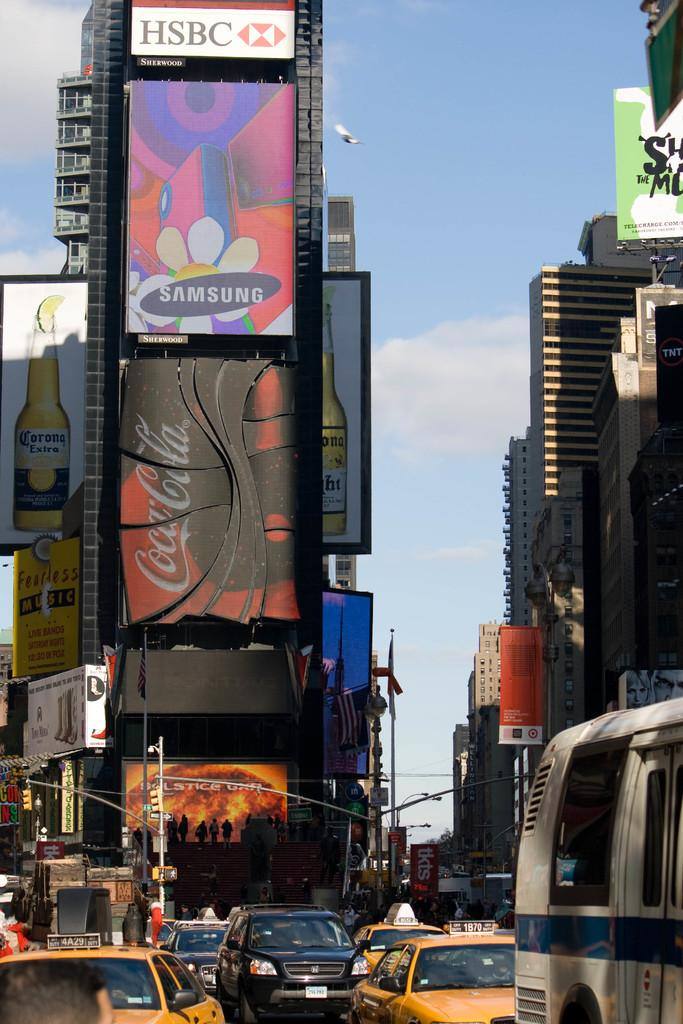<image>
Share a concise interpretation of the image provided. a coca cola sign on a building outside 